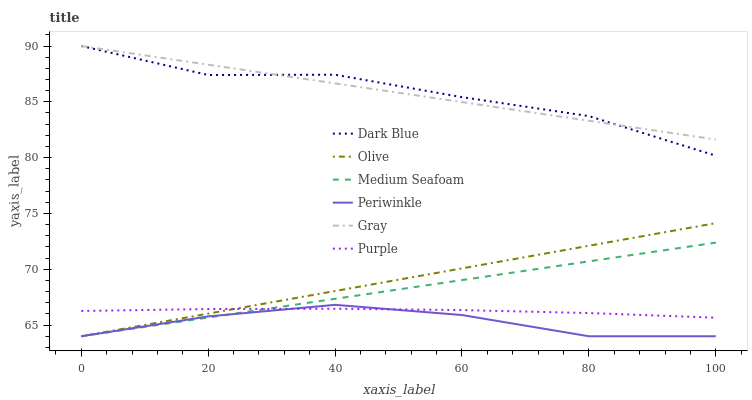Does Periwinkle have the minimum area under the curve?
Answer yes or no. Yes. Does Gray have the maximum area under the curve?
Answer yes or no. Yes. Does Purple have the minimum area under the curve?
Answer yes or no. No. Does Purple have the maximum area under the curve?
Answer yes or no. No. Is Gray the smoothest?
Answer yes or no. Yes. Is Dark Blue the roughest?
Answer yes or no. Yes. Is Purple the smoothest?
Answer yes or no. No. Is Purple the roughest?
Answer yes or no. No. Does Periwinkle have the lowest value?
Answer yes or no. Yes. Does Purple have the lowest value?
Answer yes or no. No. Does Dark Blue have the highest value?
Answer yes or no. Yes. Does Purple have the highest value?
Answer yes or no. No. Is Medium Seafoam less than Gray?
Answer yes or no. Yes. Is Dark Blue greater than Purple?
Answer yes or no. Yes. Does Purple intersect Olive?
Answer yes or no. Yes. Is Purple less than Olive?
Answer yes or no. No. Is Purple greater than Olive?
Answer yes or no. No. Does Medium Seafoam intersect Gray?
Answer yes or no. No. 